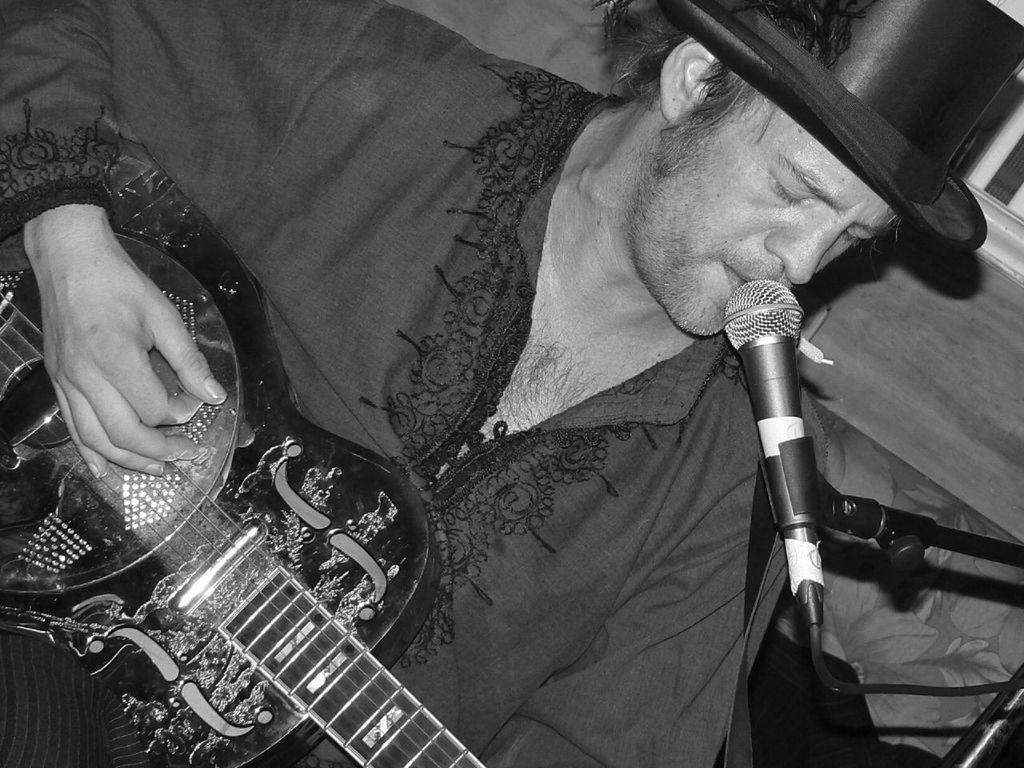What is the color scheme of the image? The image is black and white. What is the man in the image doing? The man is singing and playing a guitar. What object is the man holding in the image? The man is holding a microphone. What type of headwear is the man wearing? The man is wearing a cap. What type of suit is the man wearing in the image? There is no suit visible in the image; the man is wearing a cap. What type of print can be seen on the man's shirt in the image? There is no print visible on the man's shirt in the image, as the image is black and white. 